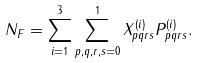Convert formula to latex. <formula><loc_0><loc_0><loc_500><loc_500>N _ { F } = \sum _ { i = 1 } ^ { 3 } \sum _ { p , q , r , s = 0 } ^ { 1 } X ^ { ( i ) } _ { p q r s } P _ { p q r s } ^ { ( i ) } .</formula> 